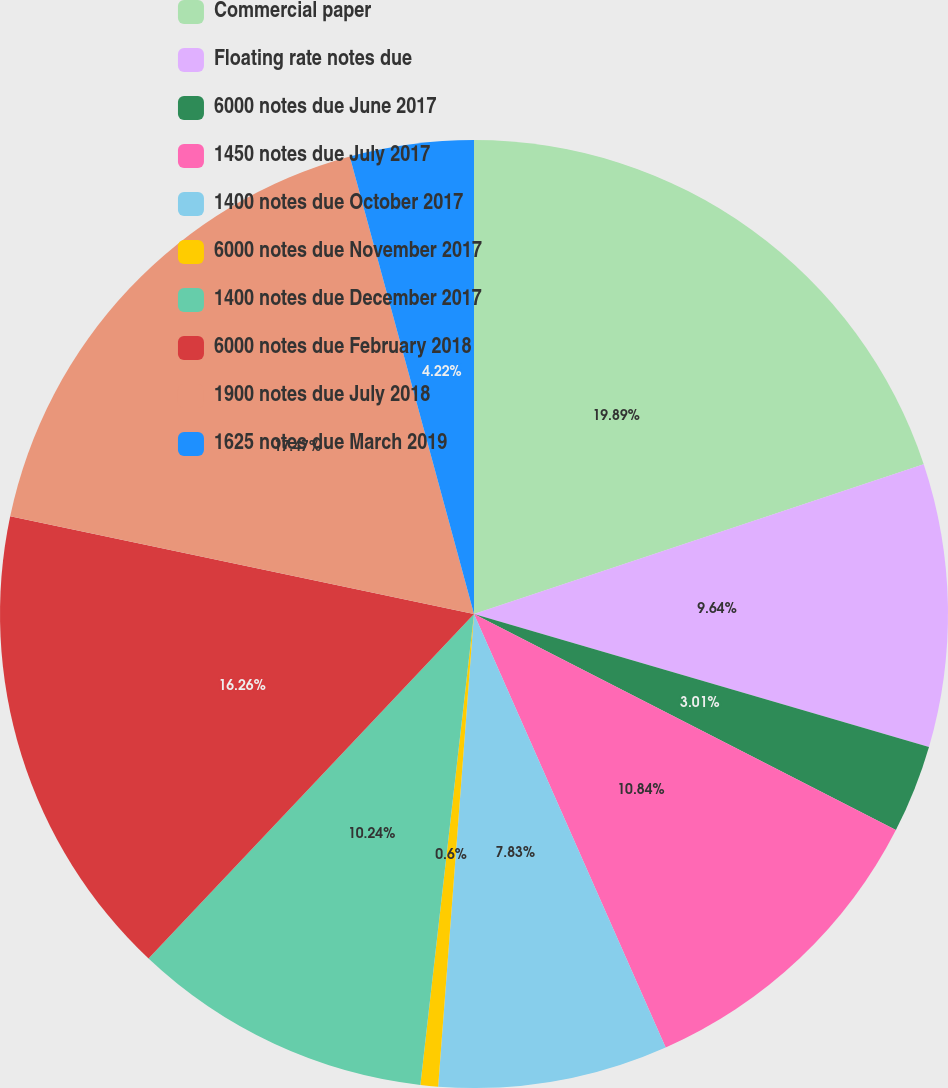<chart> <loc_0><loc_0><loc_500><loc_500><pie_chart><fcel>Commercial paper<fcel>Floating rate notes due<fcel>6000 notes due June 2017<fcel>1450 notes due July 2017<fcel>1400 notes due October 2017<fcel>6000 notes due November 2017<fcel>1400 notes due December 2017<fcel>6000 notes due February 2018<fcel>1900 notes due July 2018<fcel>1625 notes due March 2019<nl><fcel>19.88%<fcel>9.64%<fcel>3.01%<fcel>10.84%<fcel>7.83%<fcel>0.6%<fcel>10.24%<fcel>16.26%<fcel>17.47%<fcel>4.22%<nl></chart> 